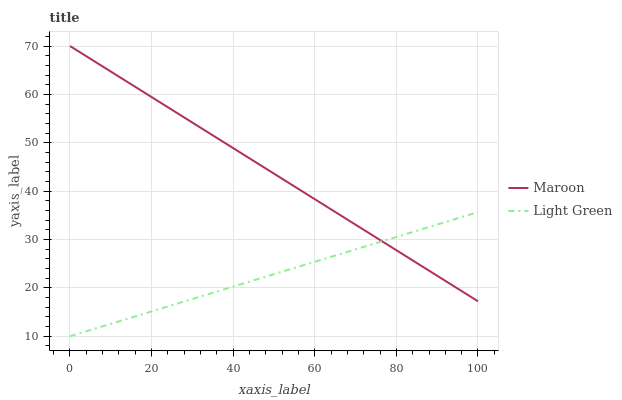Does Maroon have the minimum area under the curve?
Answer yes or no. No. Is Maroon the smoothest?
Answer yes or no. No. Does Maroon have the lowest value?
Answer yes or no. No. 